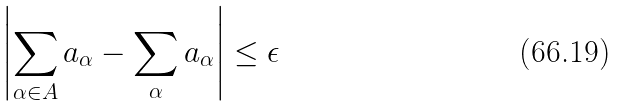<formula> <loc_0><loc_0><loc_500><loc_500>\left | \sum _ { \alpha \in A } a _ { \alpha } - \sum _ { \alpha } a _ { \alpha } \right | \leq \epsilon</formula> 